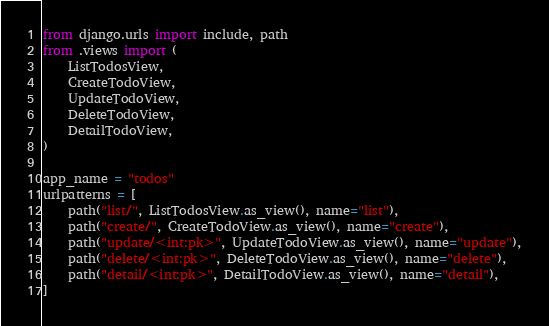<code> <loc_0><loc_0><loc_500><loc_500><_Python_>from django.urls import include, path
from .views import (
    ListTodosView,
    CreateTodoView,
    UpdateTodoView,
    DeleteTodoView,
    DetailTodoView,
)

app_name = "todos"
urlpatterns = [
    path("list/", ListTodosView.as_view(), name="list"),
    path("create/", CreateTodoView.as_view(), name="create"),
    path("update/<int:pk>", UpdateTodoView.as_view(), name="update"),
    path("delete/<int:pk>", DeleteTodoView.as_view(), name="delete"),
    path("detail/<int:pk>", DetailTodoView.as_view(), name="detail"),
]
</code> 